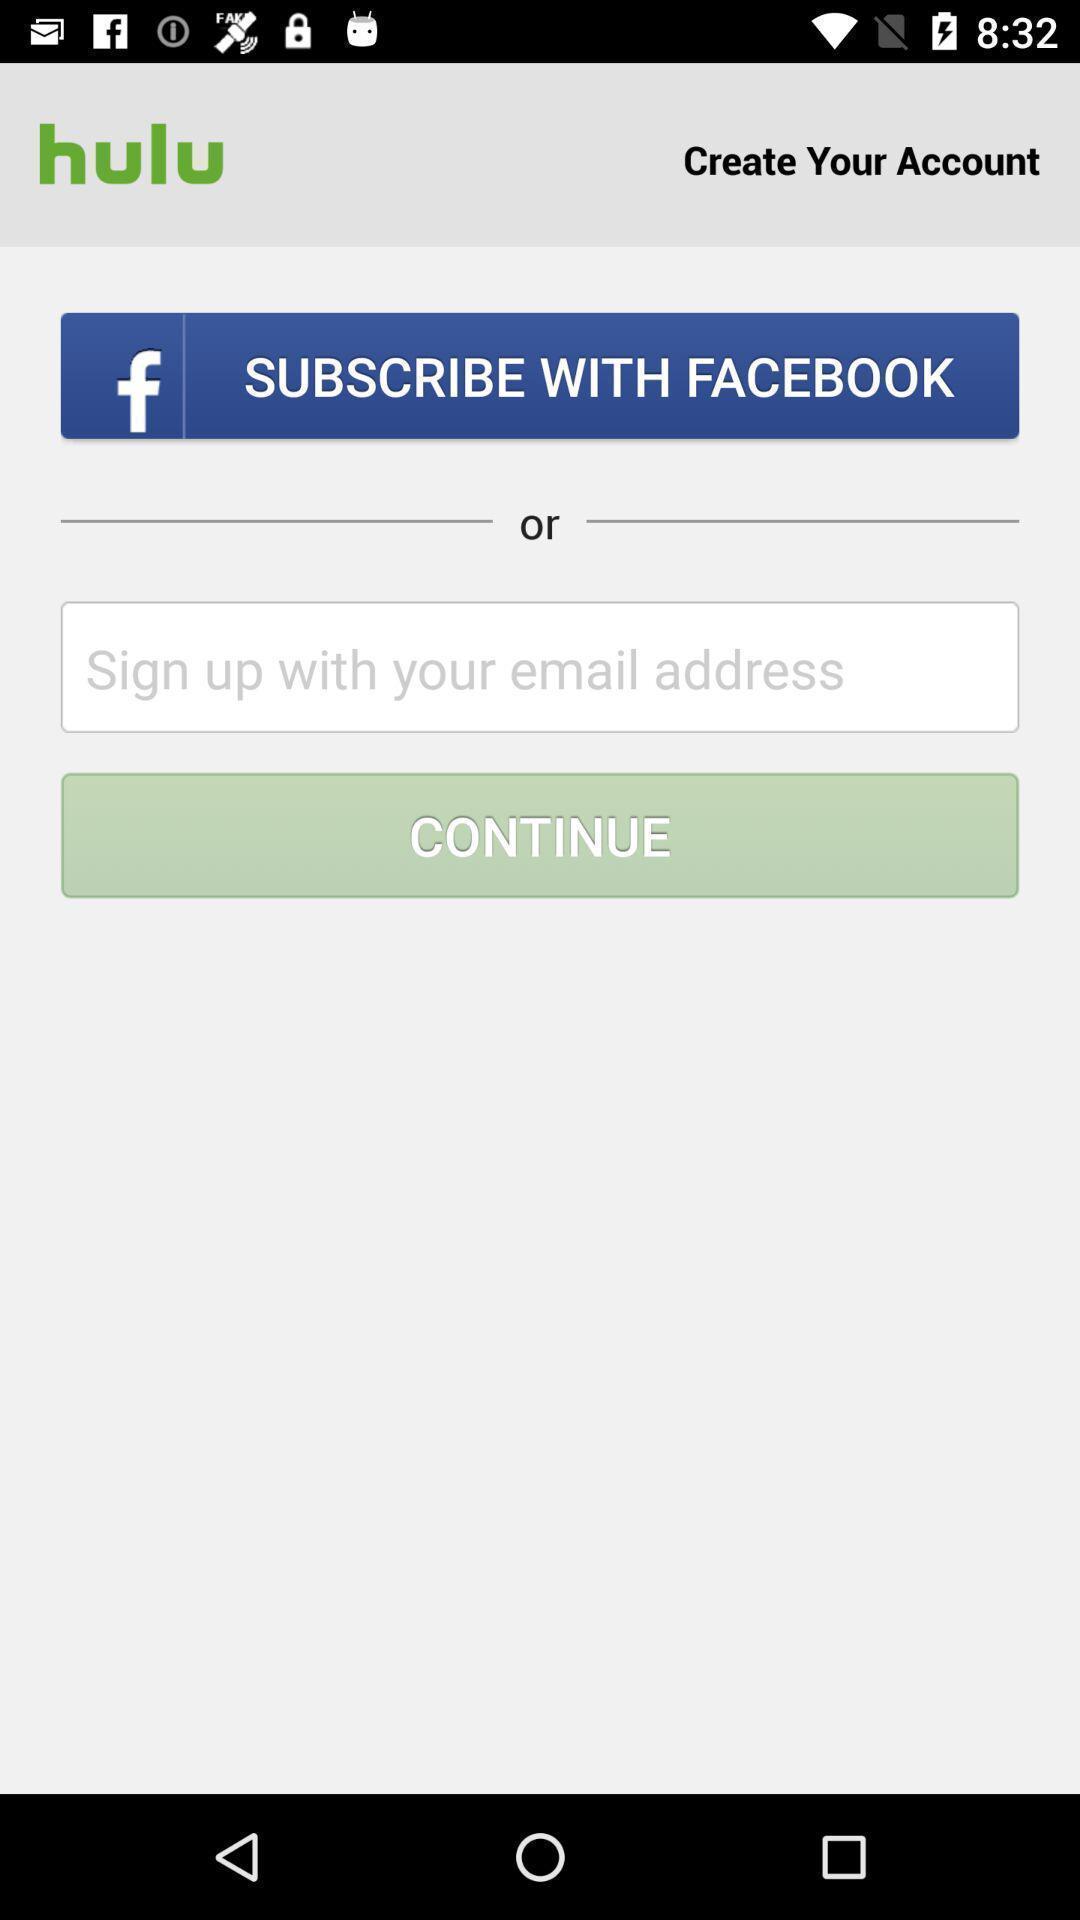Provide a textual representation of this image. Sign up page. 